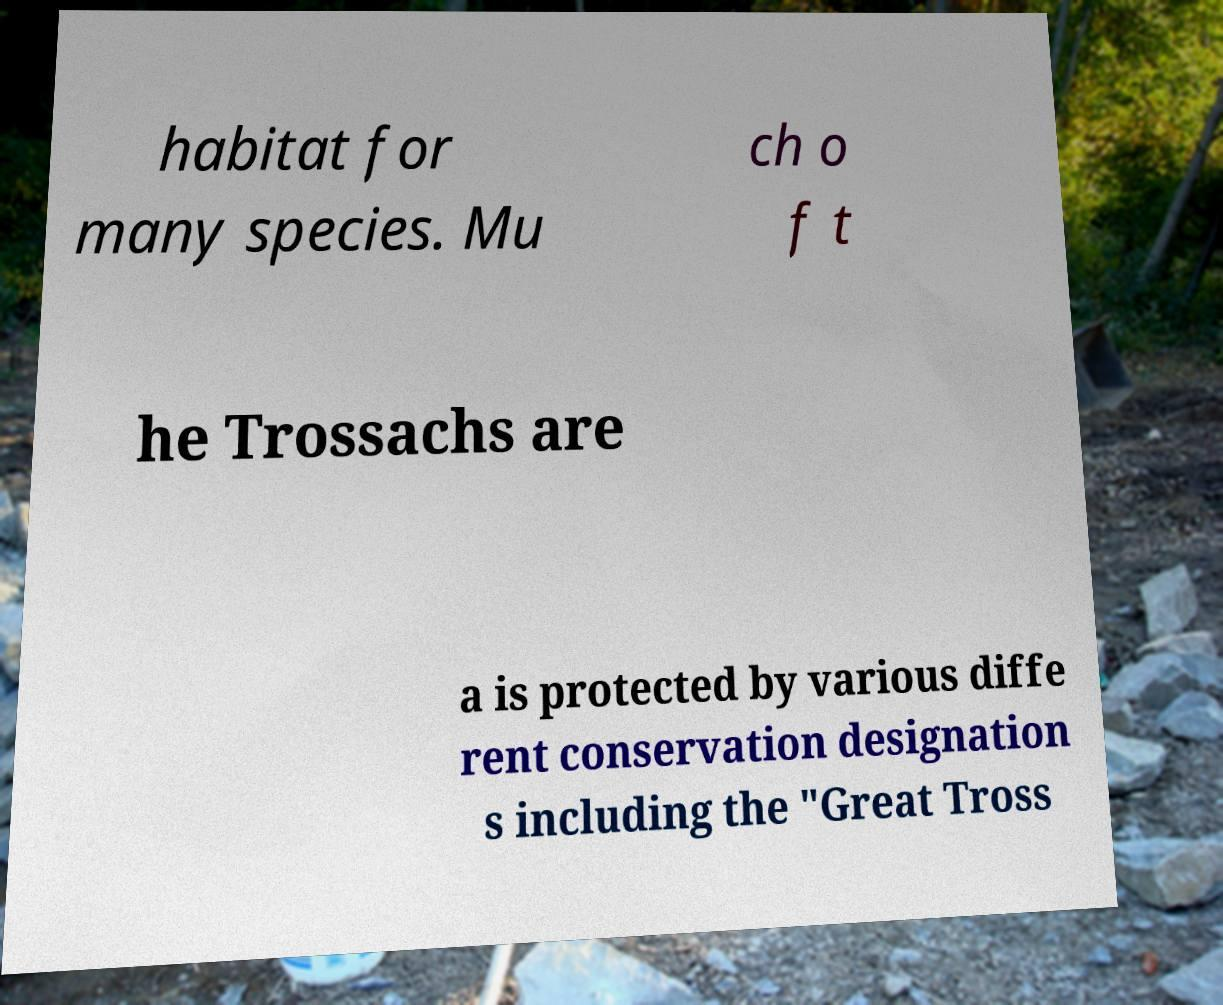For documentation purposes, I need the text within this image transcribed. Could you provide that? habitat for many species. Mu ch o f t he Trossachs are a is protected by various diffe rent conservation designation s including the "Great Tross 